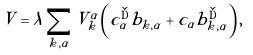Convert formula to latex. <formula><loc_0><loc_0><loc_500><loc_500>V = \lambda \sum _ { k , \alpha } V ^ { \alpha } _ { k } \left ( c ^ { \dag } _ { \alpha } b _ { k , \alpha } + c _ { \alpha } b ^ { \dag } _ { k , \alpha } \right ) ,</formula> 